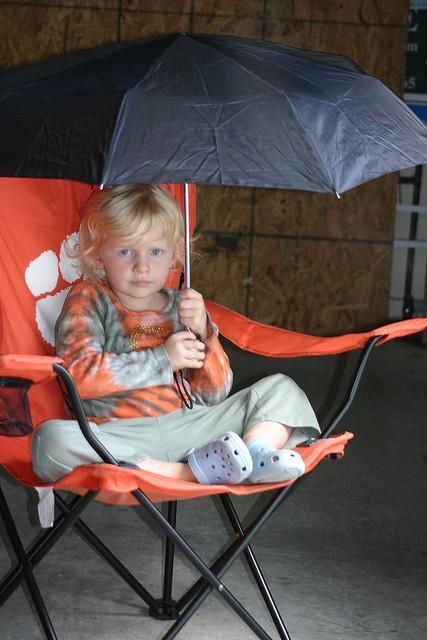Is the caption "The umbrella is above the person." a true representation of the image?
Answer yes or no. Yes. 